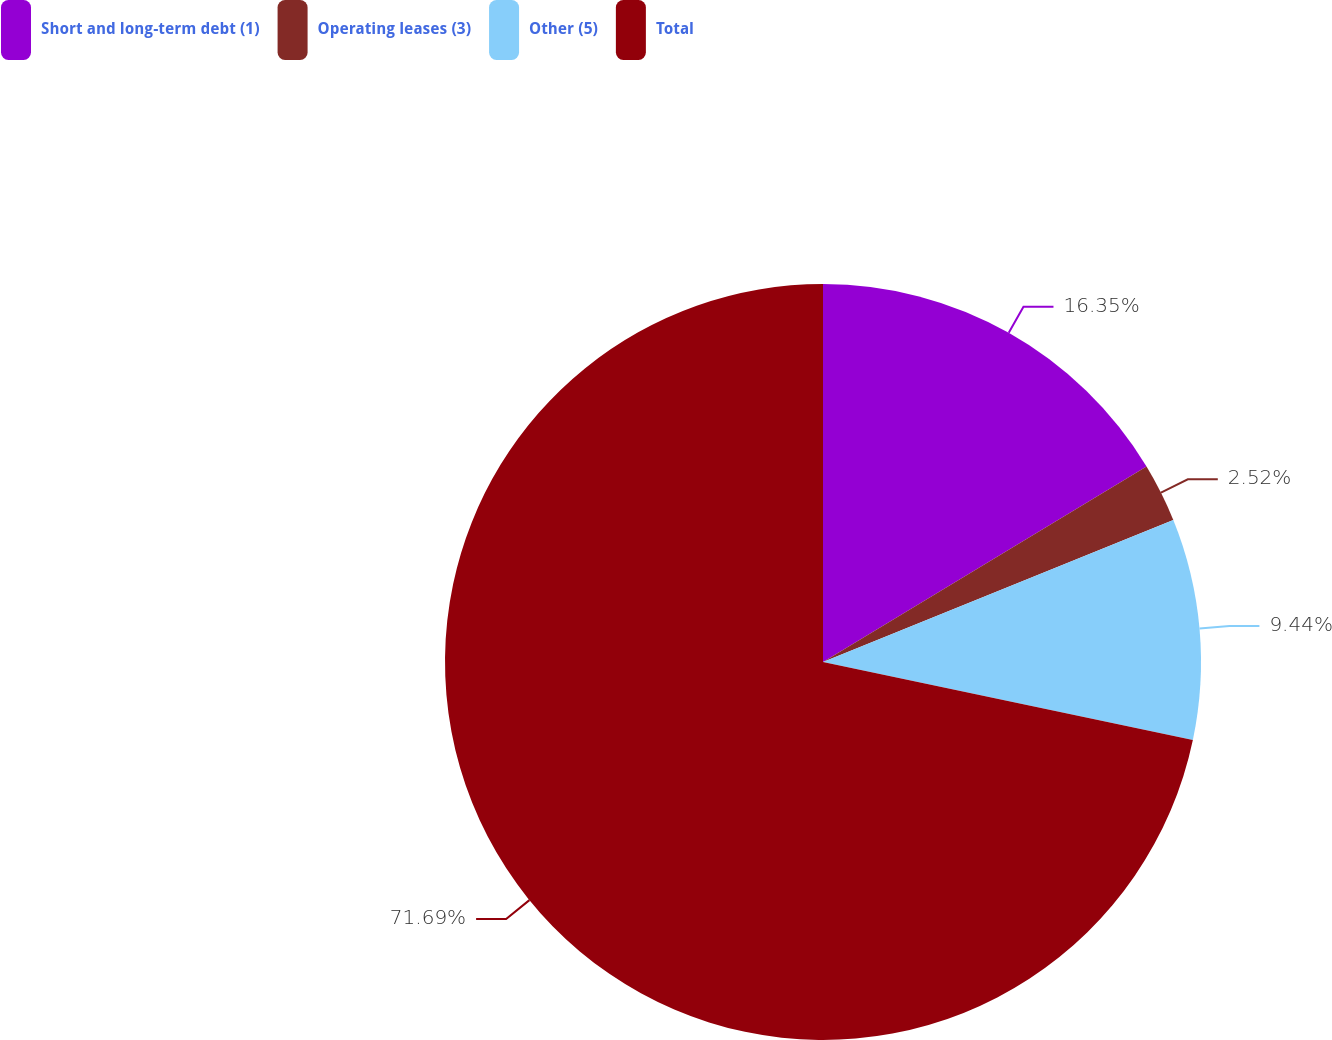Convert chart. <chart><loc_0><loc_0><loc_500><loc_500><pie_chart><fcel>Short and long-term debt (1)<fcel>Operating leases (3)<fcel>Other (5)<fcel>Total<nl><fcel>16.35%<fcel>2.52%<fcel>9.44%<fcel>71.69%<nl></chart> 